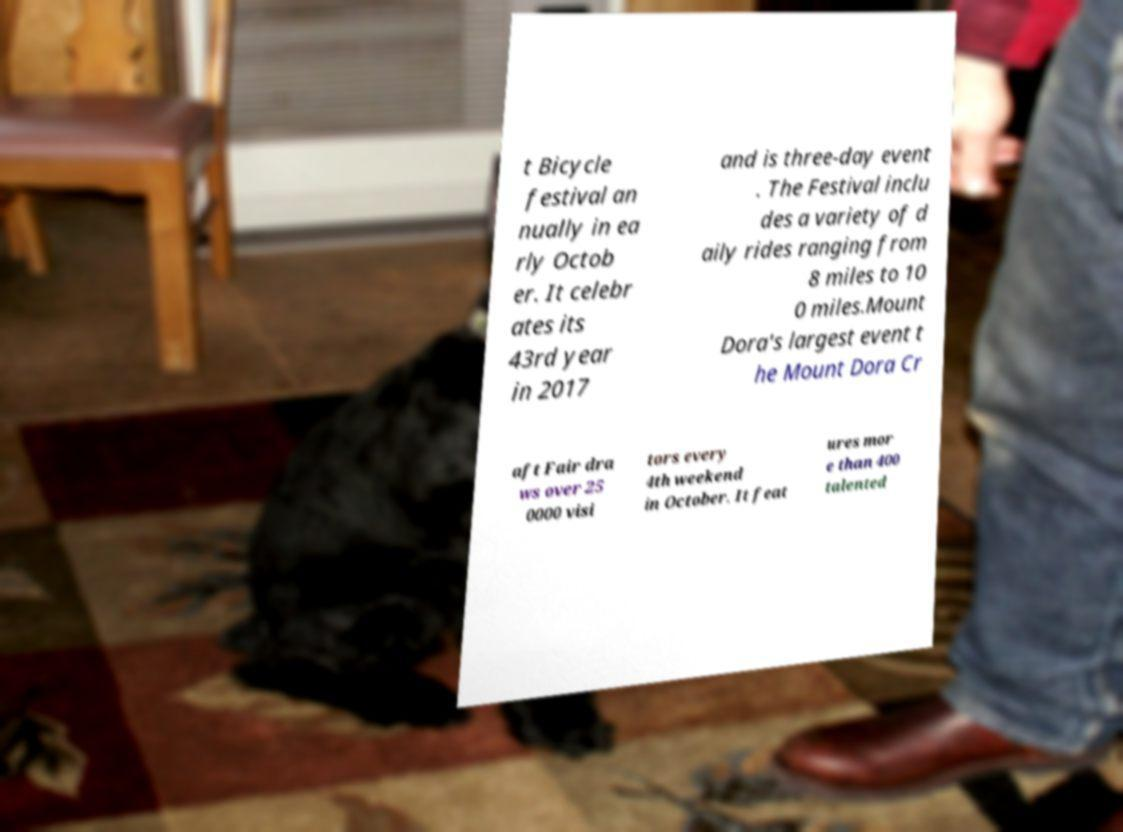Please identify and transcribe the text found in this image. t Bicycle festival an nually in ea rly Octob er. It celebr ates its 43rd year in 2017 and is three-day event . The Festival inclu des a variety of d aily rides ranging from 8 miles to 10 0 miles.Mount Dora's largest event t he Mount Dora Cr aft Fair dra ws over 25 0000 visi tors every 4th weekend in October. It feat ures mor e than 400 talented 